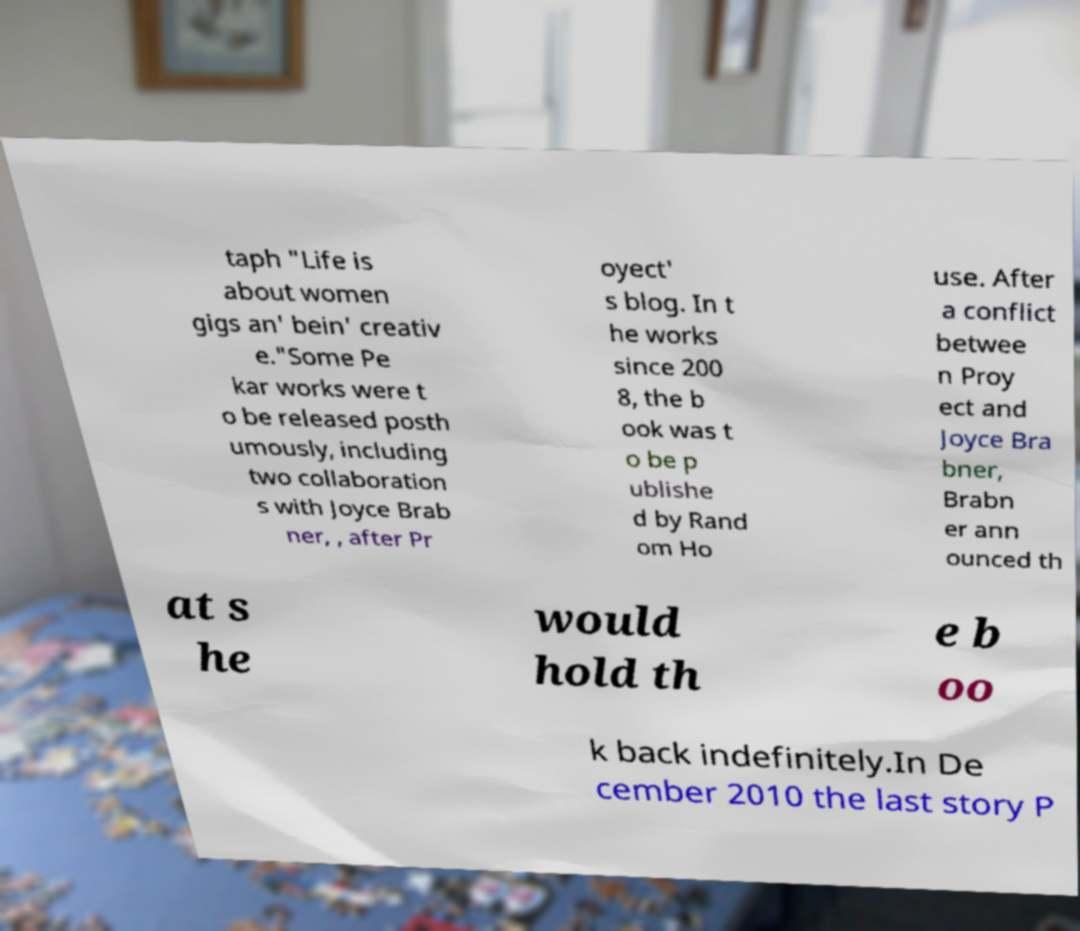Please read and relay the text visible in this image. What does it say? taph "Life is about women gigs an' bein' creativ e."Some Pe kar works were t o be released posth umously, including two collaboration s with Joyce Brab ner, , after Pr oyect' s blog. In t he works since 200 8, the b ook was t o be p ublishe d by Rand om Ho use. After a conflict betwee n Proy ect and Joyce Bra bner, Brabn er ann ounced th at s he would hold th e b oo k back indefinitely.In De cember 2010 the last story P 